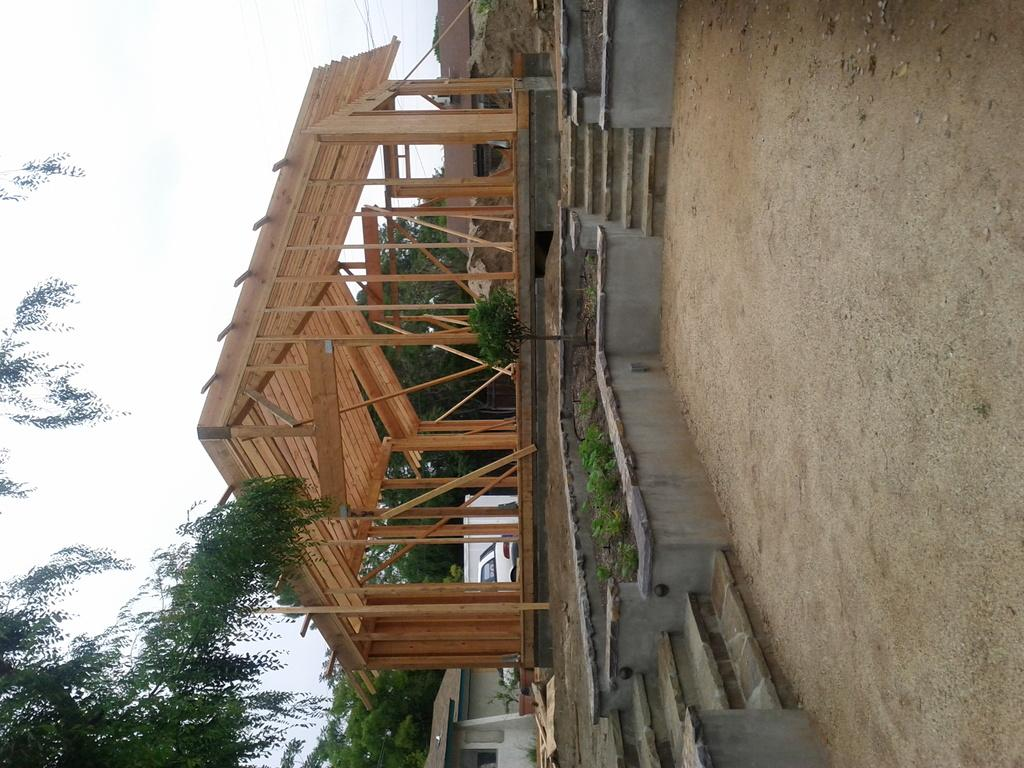What type of structure is in the image? There is a wooden roof shed in the image. What feature is present at the bottom of the shed? There are steps on the bottom side of the shed. What is the surface in front of the shed? There is a ground in front of the shed. What can be seen on the left side of the image? There is a tree on the left side of the image. What type of class is being held under the shed in the image? There is no class or any indication of a class being held in the image; it only shows a wooden roof shed with steps and a tree on the left side. What substance is being used to fly the kite in the image? There is no kite present in the image, so it is not possible to determine what substance might be used to fly a kite. 